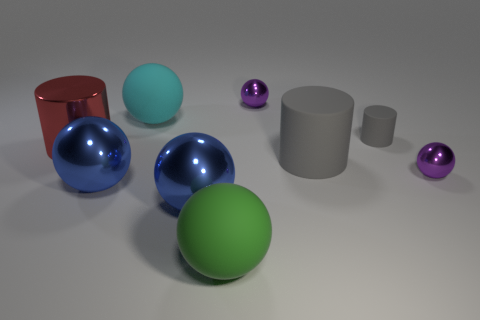There is a tiny thing that is made of the same material as the big gray thing; what is its shape?
Provide a short and direct response. Cylinder. What number of gray objects are tiny metal balls or large things?
Ensure brevity in your answer.  1. Are there any big gray cylinders behind the large red cylinder?
Your answer should be very brief. No. Is the shape of the large thing that is on the right side of the big green thing the same as the blue metal thing that is to the left of the big cyan thing?
Ensure brevity in your answer.  No. What material is the other gray object that is the same shape as the tiny matte object?
Your response must be concise. Rubber. What number of cylinders are either tiny blue metallic things or big gray matte objects?
Offer a very short reply. 1. What number of red cylinders are made of the same material as the big green object?
Your answer should be compact. 0. Is the material of the purple object behind the small gray cylinder the same as the gray thing behind the metallic cylinder?
Give a very brief answer. No. How many objects are behind the tiny purple ball on the right side of the tiny purple shiny sphere behind the large metallic cylinder?
Make the answer very short. 5. Do the large matte thing to the left of the green rubber thing and the big rubber object right of the big green sphere have the same color?
Offer a very short reply. No. 